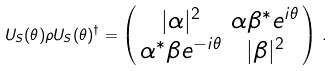<formula> <loc_0><loc_0><loc_500><loc_500>U _ { S } ( \theta ) \rho U _ { S } ( \theta ) ^ { \dag } = \left ( \begin{smallmatrix} | \alpha | ^ { 2 } & \alpha \beta ^ { \ast } e ^ { i \theta } \\ \alpha ^ { \ast } \beta e ^ { - i \theta } & | \beta | ^ { 2 } \end{smallmatrix} \right ) \, .</formula> 